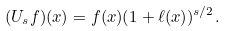<formula> <loc_0><loc_0><loc_500><loc_500>( U _ { s } f ) ( x ) = f ( x ) ( 1 + \ell ( x ) ) ^ { s / 2 } .</formula> 